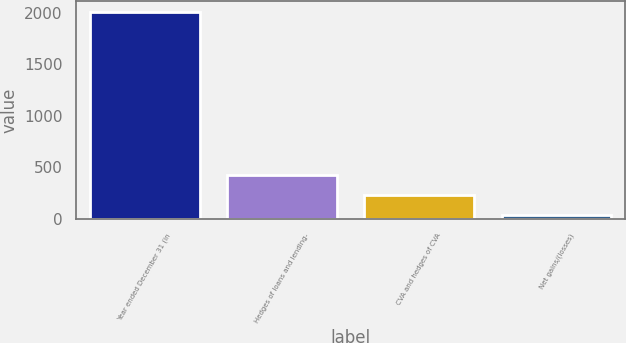Convert chart. <chart><loc_0><loc_0><loc_500><loc_500><bar_chart><fcel>Year ended December 31 (in<fcel>Hedges of loans and lending-<fcel>CVA and hedges of CVA<fcel>Net gains/(losses)<nl><fcel>2012<fcel>431.2<fcel>233.6<fcel>36<nl></chart> 